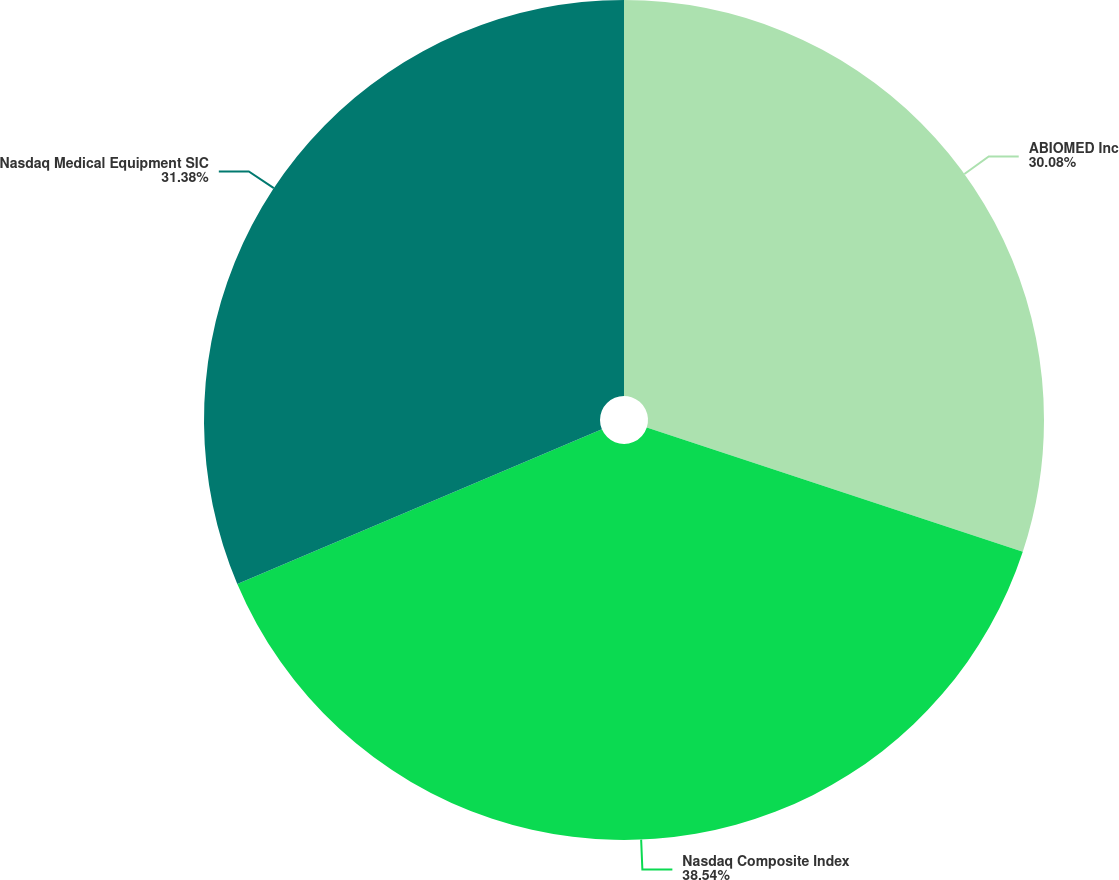<chart> <loc_0><loc_0><loc_500><loc_500><pie_chart><fcel>ABIOMED Inc<fcel>Nasdaq Composite Index<fcel>Nasdaq Medical Equipment SIC<nl><fcel>30.08%<fcel>38.54%<fcel>31.38%<nl></chart> 